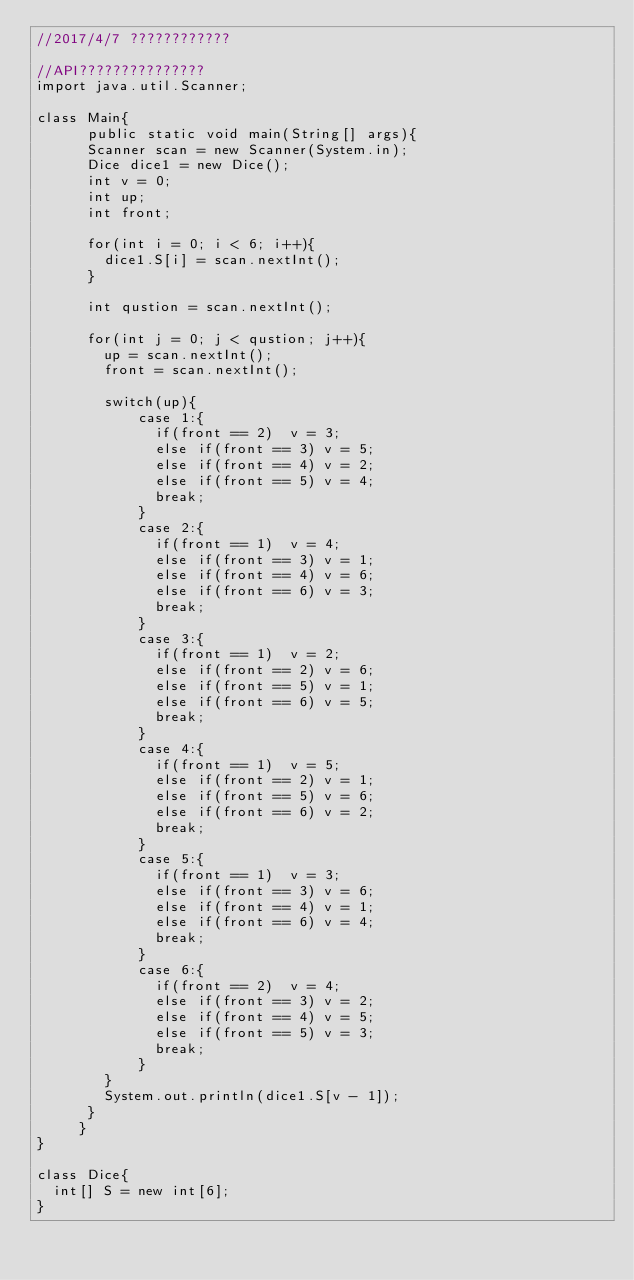Convert code to text. <code><loc_0><loc_0><loc_500><loc_500><_Java_>//2017/4/7 ????????????

//API???????????????
import java.util.Scanner;

class Main{
      public static void main(String[] args){
    	Scanner scan = new Scanner(System.in);
    	Dice dice1 = new Dice();
    	int v = 0;
    	int up;
    	int front;
    	
    	for(int i = 0; i < 6; i++){
    		dice1.S[i] = scan.nextInt();
    	}
    	
    	int qustion = scan.nextInt();
    	
    	for(int j = 0; j < qustion; j++){
    		up = scan.nextInt();
    		front = scan.nextInt();
	    	
	    	switch(up){
	    			case 1:{
	    				if(front == 2)  v = 3;
	    				else if(front == 3) v = 5;
	    				else if(front == 4) v = 2;
	    				else if(front == 5) v = 4;
	    				break;
	    			}
	    			case 2:{
	    				if(front == 1)  v = 4;
	    				else if(front == 3) v = 1;
	    				else if(front == 4) v = 6;
	    				else if(front == 6) v = 3;
	    				break;
	    			}
	    			case 3:{
	    				if(front == 1)  v = 2;
	    				else if(front == 2) v = 6;
	    				else if(front == 5) v = 1;
	    				else if(front == 6) v = 5;
	    				break;
	    			}
	    			case 4:{
	    				if(front == 1)  v = 5;
	    				else if(front == 2) v = 1;
	    				else if(front == 5) v = 6;
	    				else if(front == 6) v = 2;
	    				break;
	    			}
	    			case 5:{
	    				if(front == 1)  v = 3;
	    				else if(front == 3) v = 6;
	    				else if(front == 4) v = 1;
	    				else if(front == 6) v = 4;
	    				break;
	    			}
	    			case 6:{
	    				if(front == 2)  v = 4;
	    				else if(front == 3) v = 2;
	    				else if(front == 4) v = 5;
	    				else if(front == 5) v = 3;
	    				break;
	    			}
	    	}
	    	System.out.println(dice1.S[v - 1]);
    	}
     }
}

class Dice{
	int[] S = new int[6];
}</code> 